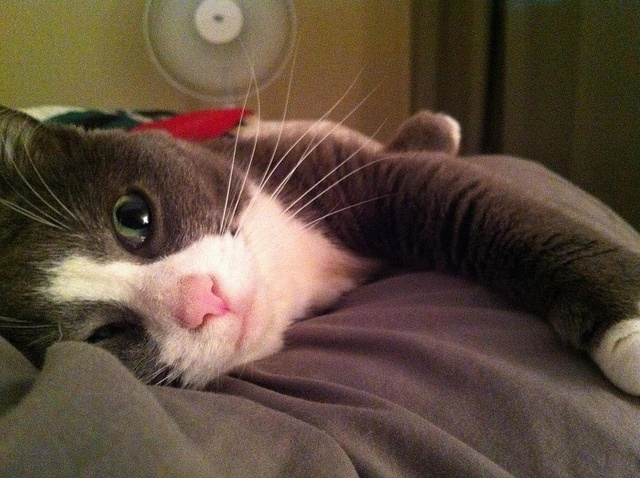Describe the objects in this image and their specific colors. I can see cat in olive, black, maroon, gray, and lightpink tones and bed in olive, gray, and black tones in this image. 